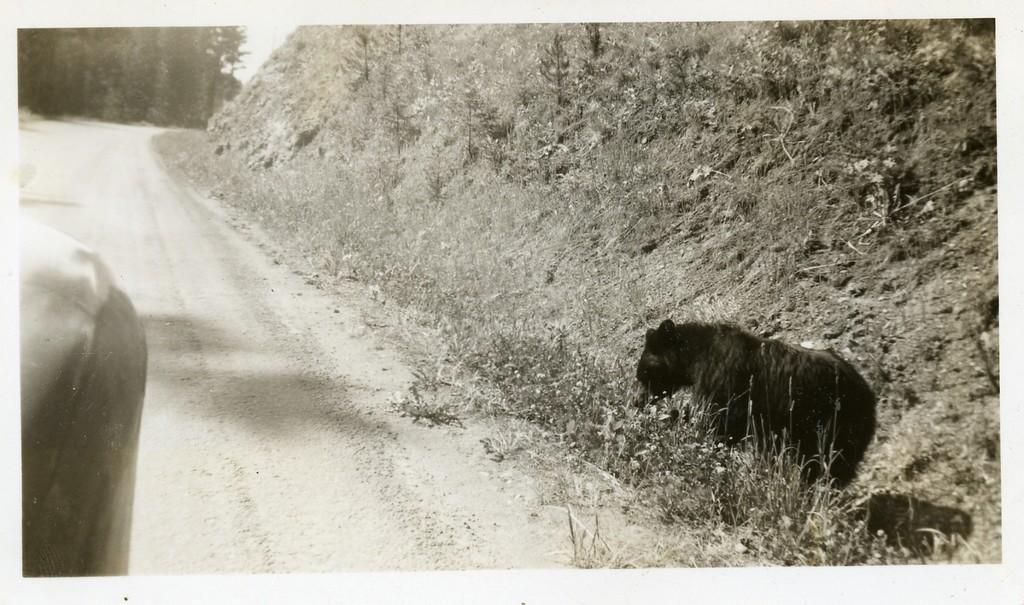What is the main feature of the image? There is a road in the image. Where is the road located in the image? The road is at the center of the image. What can be seen beside the road? There is a bear beside the road. What type of surface is visible in the image? Grass is visible on the surface. What can be seen in the background of the image? There are trees in the background of the image. How many babies are present in the image? There are no babies present in the image. What type of tree is the bear climbing in the image? There is no tree in the image for the bear to climb; it is beside the road. 